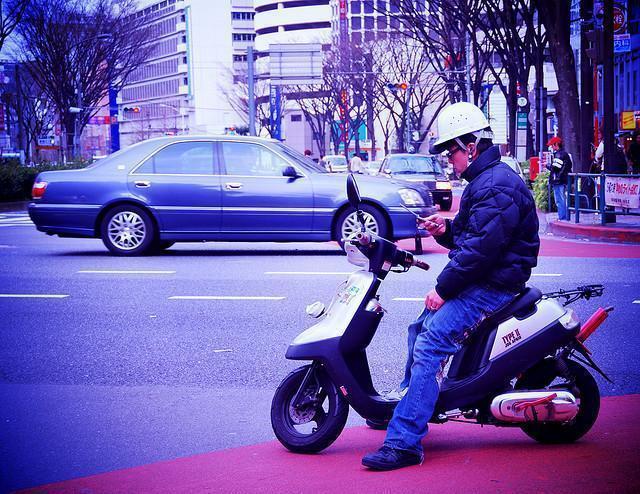In what country is this street found?
Make your selection from the four choices given to correctly answer the question.
Options: Japan, north korea, south korea, china. Japan. 